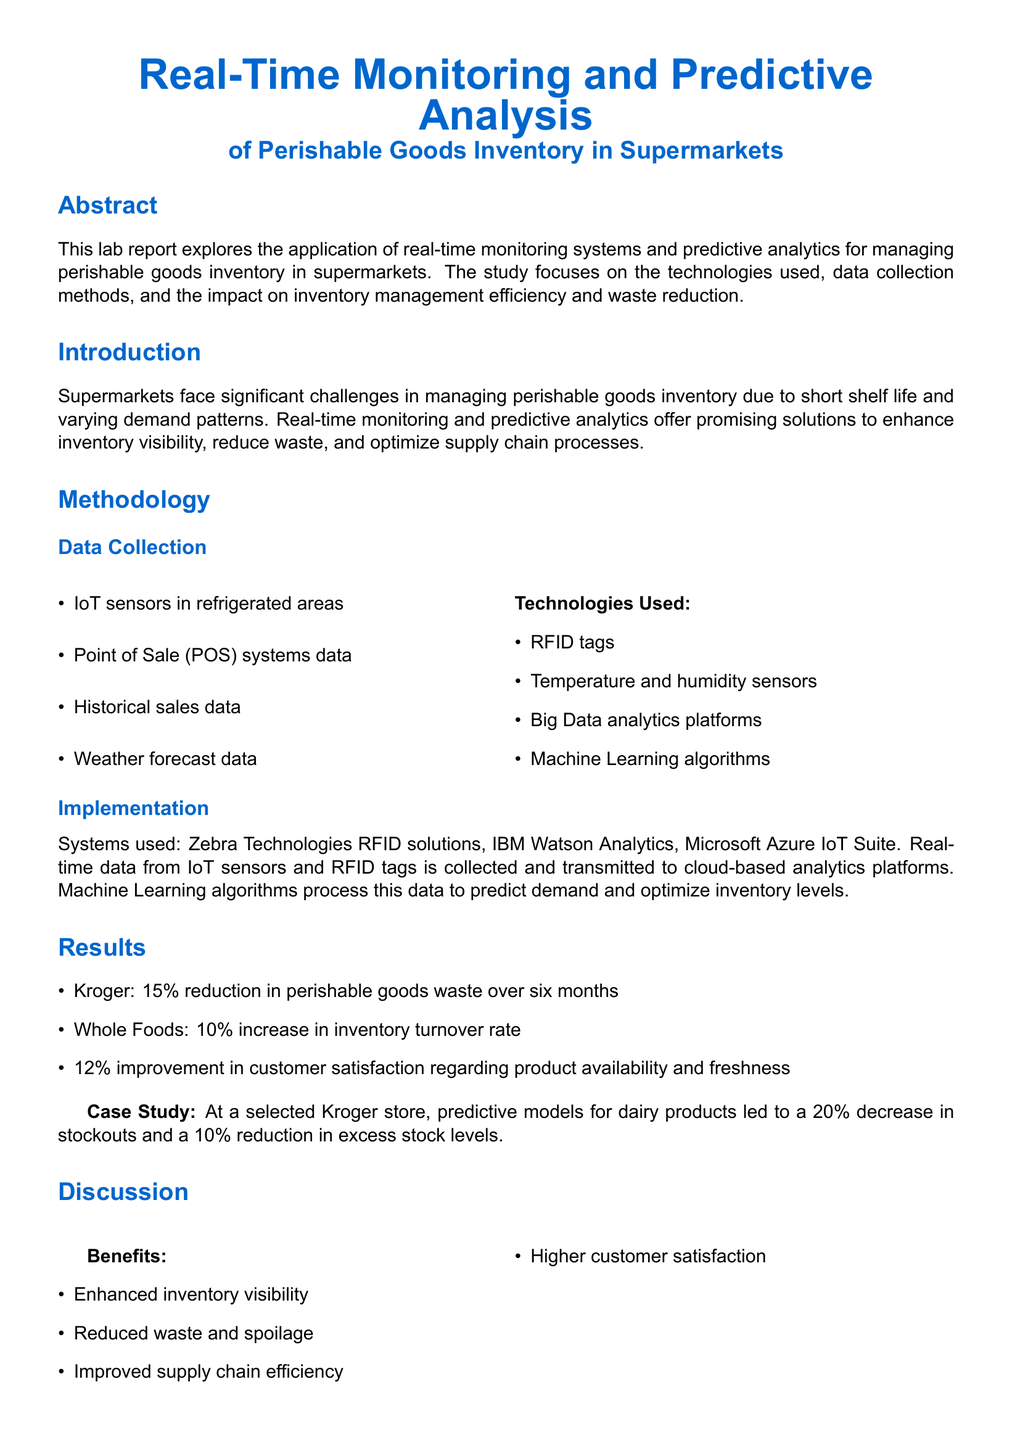What is the main focus of the study? The study focuses on real-time monitoring systems and predictive analytics for managing perishable goods inventory in supermarkets.
Answer: Real-time monitoring systems and predictive analytics What technologies are used for data collection? Technologies mentioned include RFID tags, temperature and humidity sensors, Big Data analytics platforms, and Machine Learning algorithms.
Answer: RFID tags, temperature and humidity sensors, Big Data analytics platforms, Machine Learning algorithms What was the reduction in perishable goods waste reported by Kroger? Kroger reported a 15% reduction in perishable goods waste over six months.
Answer: 15% What improvement in inventory turnover rate was observed at Whole Foods? Whole Foods experienced a 10% increase in inventory turnover rate.
Answer: 10% What is one challenge mentioned in the discussion? A challenge mentioned is high initial investment costs.
Answer: High initial investment costs Which case study product saw a 20% decrease in stockouts? The case study focused on dairy products in a selected Kroger store.
Answer: Dairy products What is one benefit of implementing real-time monitoring systems? One benefit is enhanced inventory visibility.
Answer: Enhanced inventory visibility What future research focus is suggested in the conclusion? Future research should focus on integrating advanced AI techniques and exploring blockchain technology.
Answer: Integrating advanced AI techniques and exploring blockchain technology What is the improvement in customer satisfaction regarding product availability and freshness? There was a 12% improvement in customer satisfaction.
Answer: 12% 